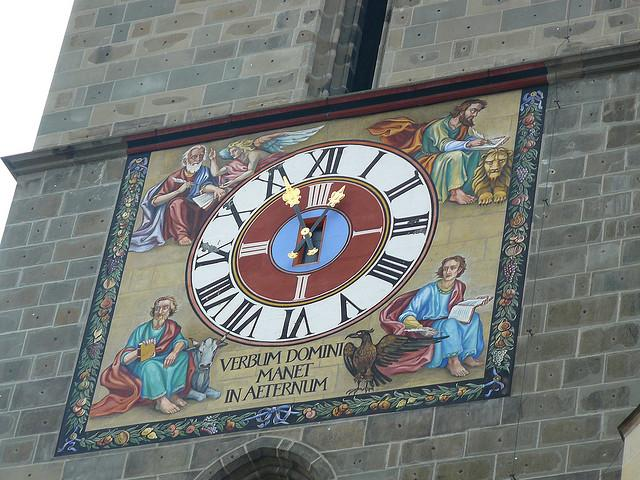What language are the words on the clock written in? Please explain your reasoning. latin. They are in a foreign language. 